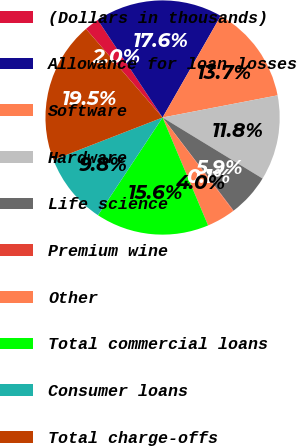Convert chart to OTSL. <chart><loc_0><loc_0><loc_500><loc_500><pie_chart><fcel>(Dollars in thousands)<fcel>Allowance for loan losses<fcel>Software<fcel>Hardware<fcel>Life science<fcel>Premium wine<fcel>Other<fcel>Total commercial loans<fcel>Consumer loans<fcel>Total charge-offs<nl><fcel>2.01%<fcel>17.6%<fcel>13.7%<fcel>11.75%<fcel>5.91%<fcel>0.06%<fcel>3.96%<fcel>15.65%<fcel>9.81%<fcel>19.55%<nl></chart> 